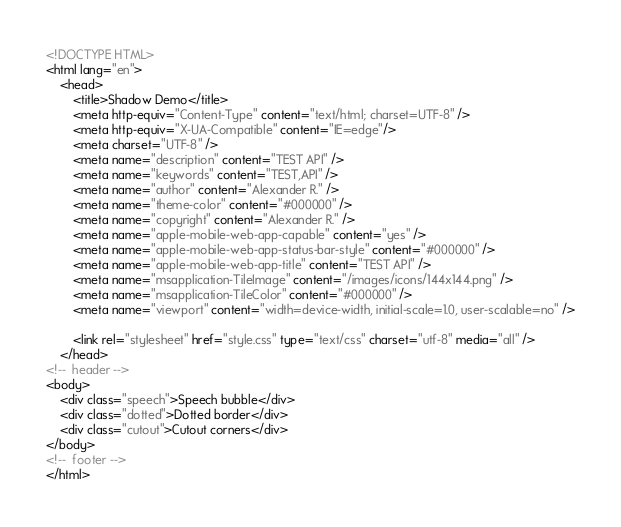<code> <loc_0><loc_0><loc_500><loc_500><_HTML_><!DOCTYPE HTML>
<html lang="en">
    <head>
        <title>Shadow Demo</title>
        <meta http-equiv="Content-Type" content="text/html; charset=UTF-8" />
        <meta http-equiv="X-UA-Compatible" content="IE=edge"/>
        <meta charset="UTF-8" />
        <meta name="description" content="TEST API" />
        <meta name="keywords" content="TEST,API" />
        <meta name="author" content="Alexander R." />
        <meta name="theme-color" content="#000000" />
        <meta name="copyright" content="Alexander R." />
        <meta name="apple-mobile-web-app-capable" content="yes" />
        <meta name="apple-mobile-web-app-status-bar-style" content="#000000" />
        <meta name="apple-mobile-web-app-title" content="TEST API" />
        <meta name="msapplication-TileImage" content="/images/icons/144x144.png" />
        <meta name="msapplication-TileColor" content="#000000" />
        <meta name="viewport" content="width=device-width, initial-scale=1.0, user-scalable=no" />

        <link rel="stylesheet" href="style.css" type="text/css" charset="utf-8" media="all" />
    </head>
<!--  header -->
<body>
    <div class="speech">Speech bubble</div>
    <div class="dotted">Dotted border</div>
    <div class="cutout">Cutout corners</div>
</body>
<!--  footer -->
</html>
</code> 